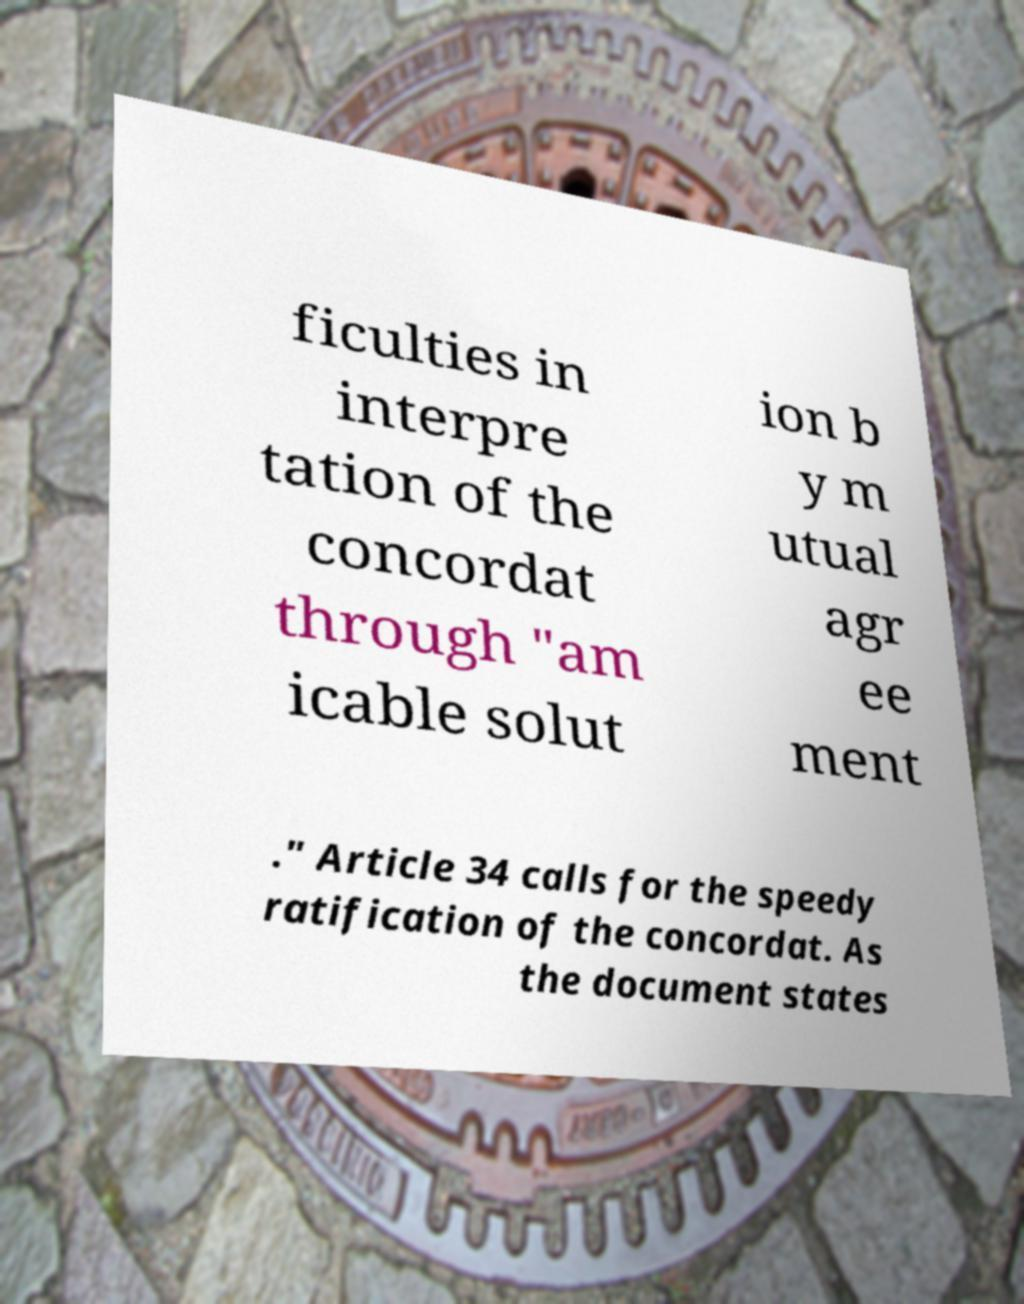Please identify and transcribe the text found in this image. ficulties in interpre tation of the concordat through "am icable solut ion b y m utual agr ee ment ." Article 34 calls for the speedy ratification of the concordat. As the document states 